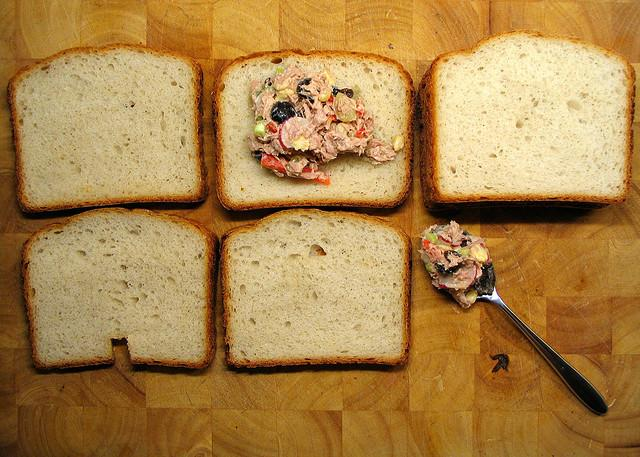How many slices of bread will filling be put on? Please explain your reasoning. three. There are 5 slices, and 2 slices are saved to be the top and bottoms 